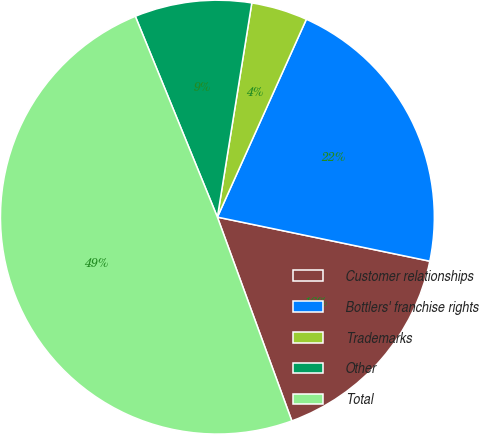<chart> <loc_0><loc_0><loc_500><loc_500><pie_chart><fcel>Customer relationships<fcel>Bottlers' franchise rights<fcel>Trademarks<fcel>Other<fcel>Total<nl><fcel>16.17%<fcel>21.53%<fcel>4.19%<fcel>8.71%<fcel>49.4%<nl></chart> 